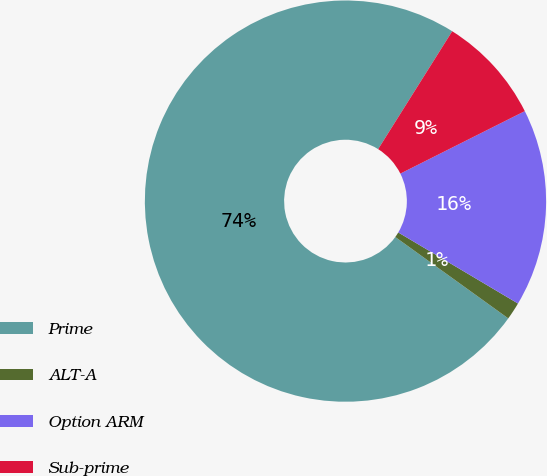Convert chart. <chart><loc_0><loc_0><loc_500><loc_500><pie_chart><fcel>Prime<fcel>ALT-A<fcel>Option ARM<fcel>Sub-prime<nl><fcel>74.0%<fcel>1.41%<fcel>15.93%<fcel>8.67%<nl></chart> 